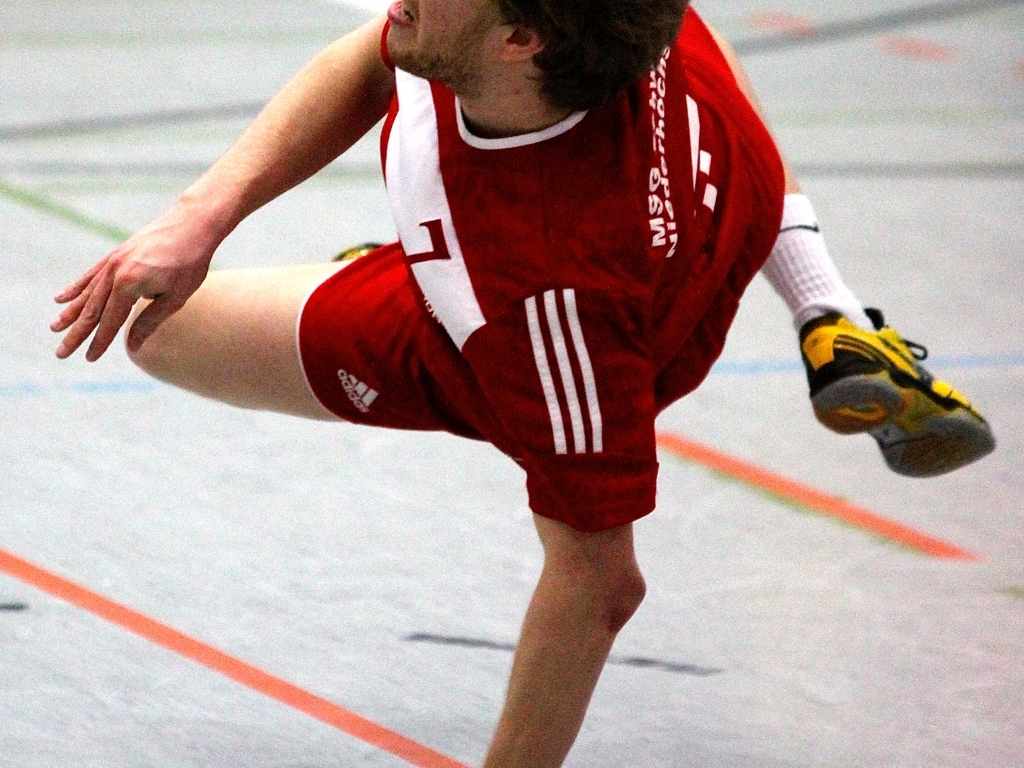What can we infer about the environment where this activity is taking place? The image shows an indoor setting with a shiny, polished floor that implies a gymnasium or sports arena specifically designed for indoor activities such as handball, basketball, or volleyball. 